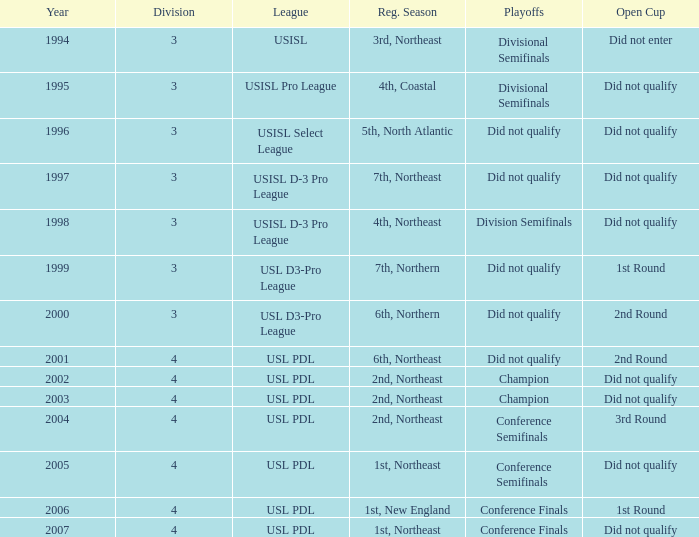What was the league called in 2003? USL PDL. 